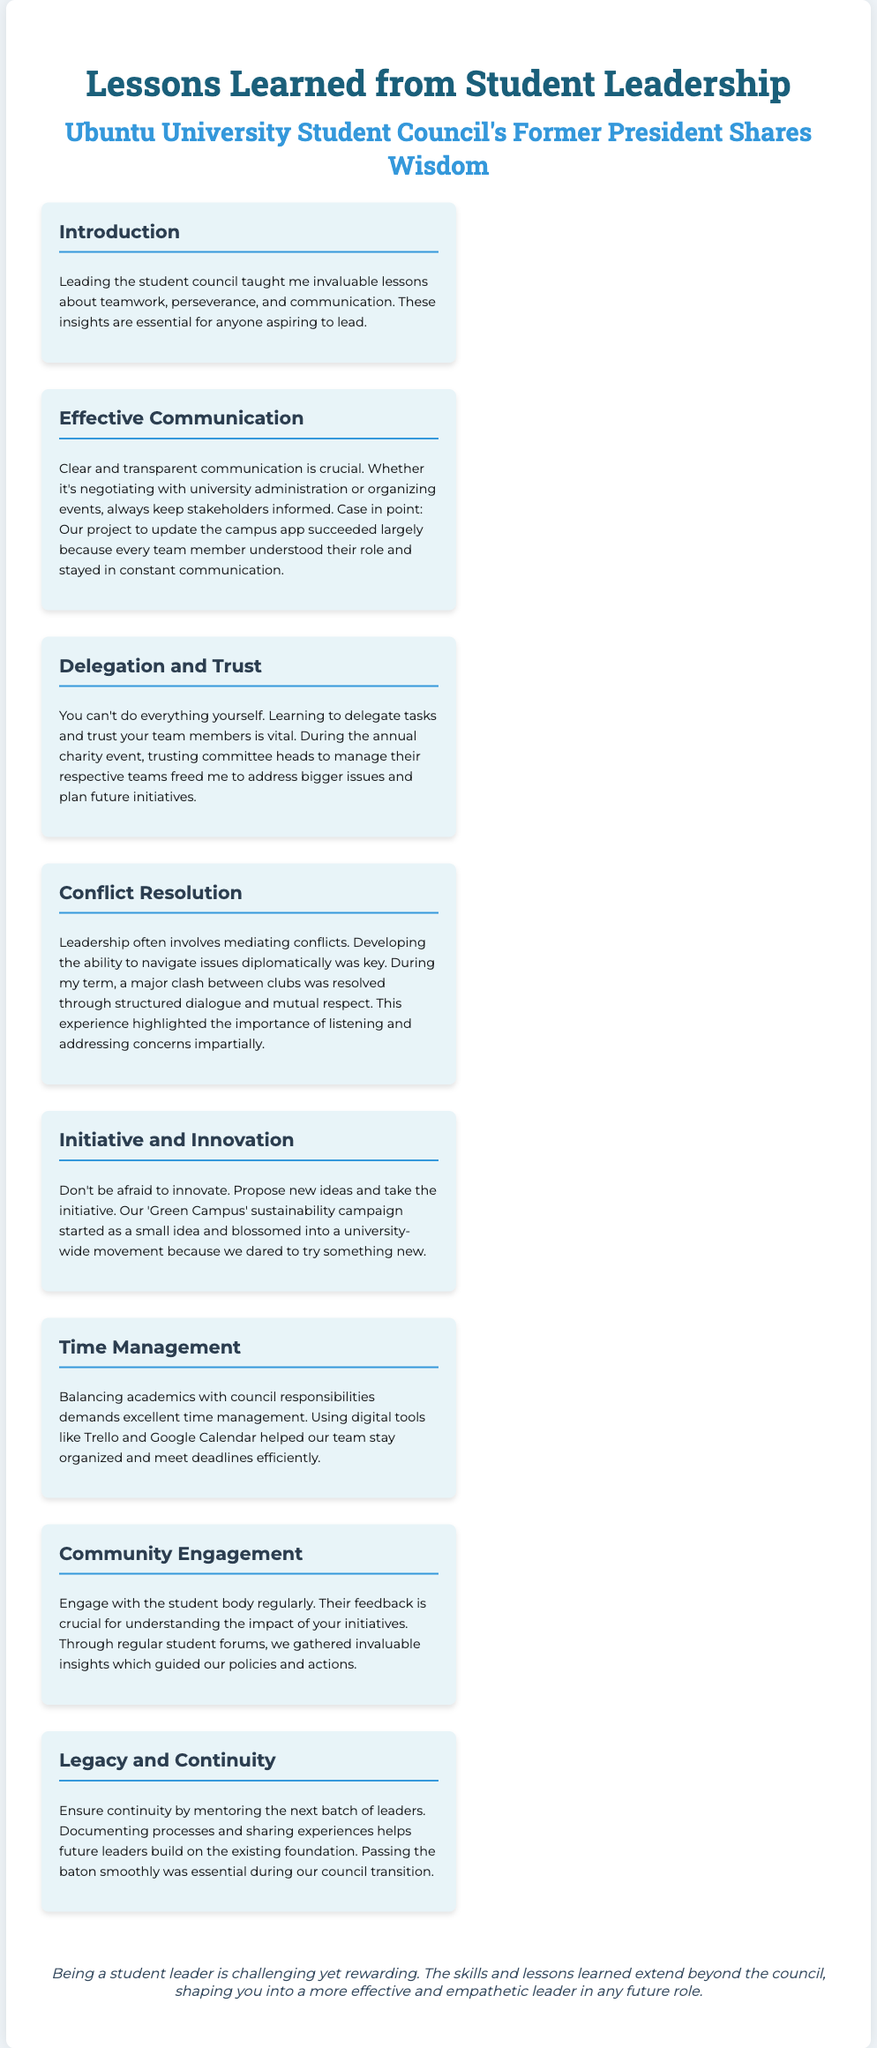what is the title of the poster? The title of the poster is stated prominently at the top of the document, summarizing its main theme.
Answer: Lessons Learned from Student Leadership who shares wisdom in the poster? The poster indicates that wisdom is shared by a former student council president, which implies leadership experience.
Answer: Ubuntu University Student Council's Former President what lesson emphasizes the importance of communication? This lesson specifically highlights the significance of sharing information among team members and stakeholders in leadership roles.
Answer: Effective Communication what is a significant aspect of the delegation lesson? This aspect focuses on the necessity of trusting team members to manage their tasks while the leader focuses on larger issues.
Answer: Trust which campaign is mentioned as an example of innovation? The example of innovation in the document discusses a particular initiative that grew into a broader movement due to creative thinking.
Answer: Green Campus how does the poster suggest handling community engagement? The poster mentions a method for understanding the student body's needs and perceptions regarding the council’s initiatives.
Answer: Regular student forums what digital tools are recommended for time management? The document lists specific digital tools that assist in maintaining organization in leadership roles, making it easier to balance multiple responsibilities.
Answer: Trello and Google Calendar what is mentioned as essential for ensuring continuity across leadership transitions? This aspect refers to the importance of preparing future leaders and maintaining established practices within the council structure.
Answer: Mentoring the next batch of leaders what do the closing remarks imply about the experience of being a student leader? The closing remarks summarize the overall sentiment of the leadership experience, emphasizing its dual nature regarding challenges and rewards.
Answer: Challenging yet rewarding 